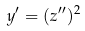Convert formula to latex. <formula><loc_0><loc_0><loc_500><loc_500>y ^ { \prime } = ( z ^ { \prime \prime } ) ^ { 2 }</formula> 